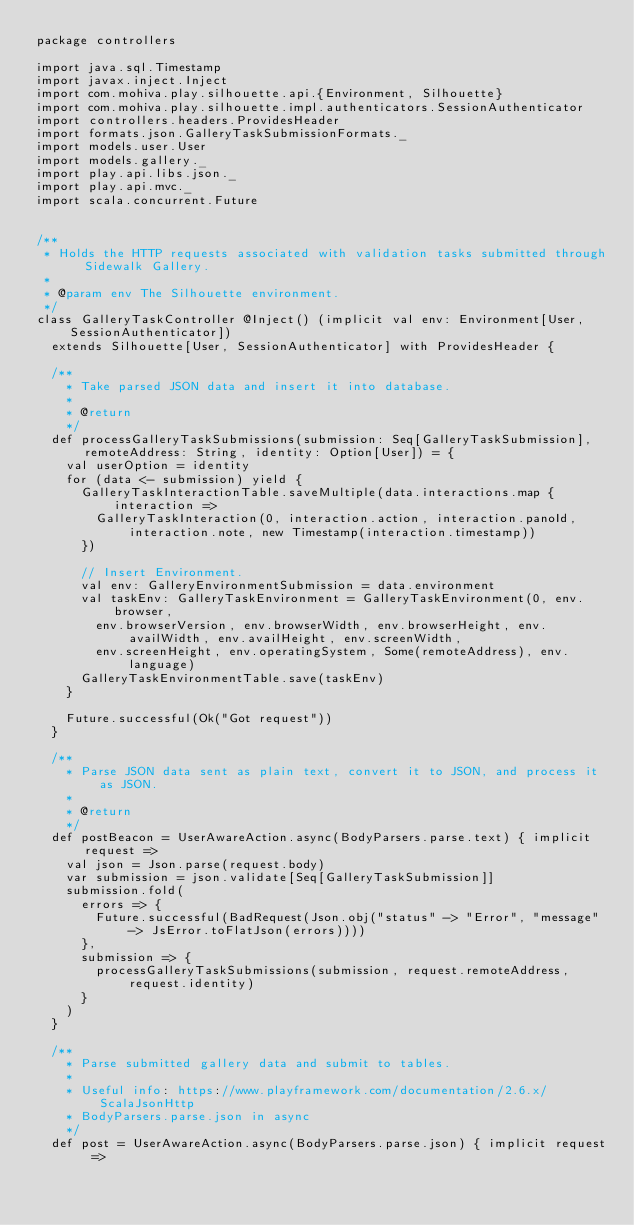Convert code to text. <code><loc_0><loc_0><loc_500><loc_500><_Scala_>package controllers

import java.sql.Timestamp
import javax.inject.Inject
import com.mohiva.play.silhouette.api.{Environment, Silhouette}
import com.mohiva.play.silhouette.impl.authenticators.SessionAuthenticator
import controllers.headers.ProvidesHeader
import formats.json.GalleryTaskSubmissionFormats._
import models.user.User
import models.gallery._
import play.api.libs.json._
import play.api.mvc._
import scala.concurrent.Future


/**
 * Holds the HTTP requests associated with validation tasks submitted through Sidewalk Gallery.
 *
 * @param env The Silhouette environment.
 */
class GalleryTaskController @Inject() (implicit val env: Environment[User, SessionAuthenticator])
  extends Silhouette[User, SessionAuthenticator] with ProvidesHeader {

  /**
    * Take parsed JSON data and insert it into database.
    *
    * @return
    */
  def processGalleryTaskSubmissions(submission: Seq[GalleryTaskSubmission], remoteAddress: String, identity: Option[User]) = {
    val userOption = identity
    for (data <- submission) yield {
      GalleryTaskInteractionTable.saveMultiple(data.interactions.map { interaction =>
        GalleryTaskInteraction(0, interaction.action, interaction.panoId, interaction.note, new Timestamp(interaction.timestamp))
      })

      // Insert Environment.
      val env: GalleryEnvironmentSubmission = data.environment
      val taskEnv: GalleryTaskEnvironment = GalleryTaskEnvironment(0, env.browser,
        env.browserVersion, env.browserWidth, env.browserHeight, env.availWidth, env.availHeight, env.screenWidth,
        env.screenHeight, env.operatingSystem, Some(remoteAddress), env.language)
      GalleryTaskEnvironmentTable.save(taskEnv)
    }
    
    Future.successful(Ok("Got request"))
  }

  /**
    * Parse JSON data sent as plain text, convert it to JSON, and process it as JSON.
    *
    * @return
    */
  def postBeacon = UserAwareAction.async(BodyParsers.parse.text) { implicit request =>
    val json = Json.parse(request.body)
    var submission = json.validate[Seq[GalleryTaskSubmission]]
    submission.fold(
      errors => {
        Future.successful(BadRequest(Json.obj("status" -> "Error", "message" -> JsError.toFlatJson(errors))))
      },
      submission => {
        processGalleryTaskSubmissions(submission, request.remoteAddress, request.identity)
      }
    )
  }

  /**
    * Parse submitted gallery data and submit to tables.
    *
    * Useful info: https://www.playframework.com/documentation/2.6.x/ScalaJsonHttp 
    * BodyParsers.parse.json in async
    */
  def post = UserAwareAction.async(BodyParsers.parse.json) { implicit request =></code> 